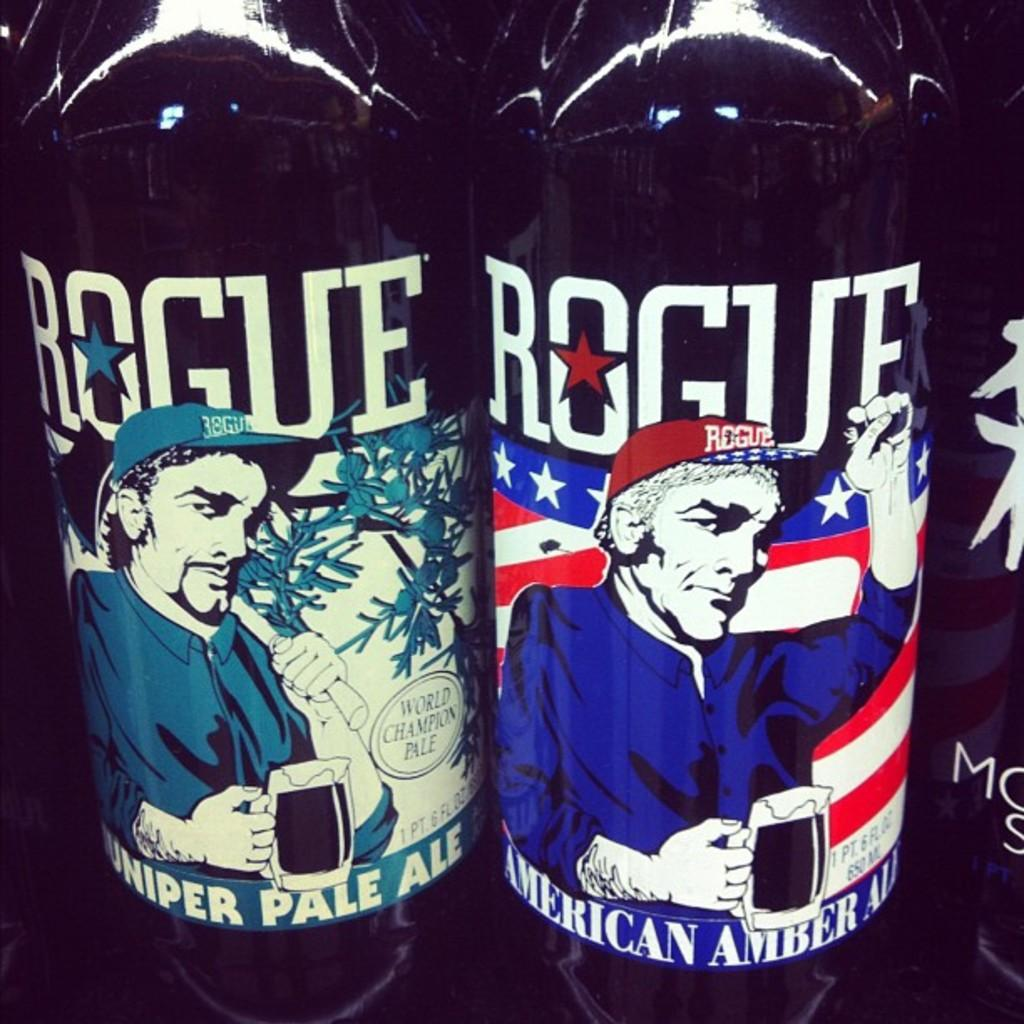Provide a one-sentence caption for the provided image. Two bottles of Rogue ales sit next to each other, one with a more colorful label. 